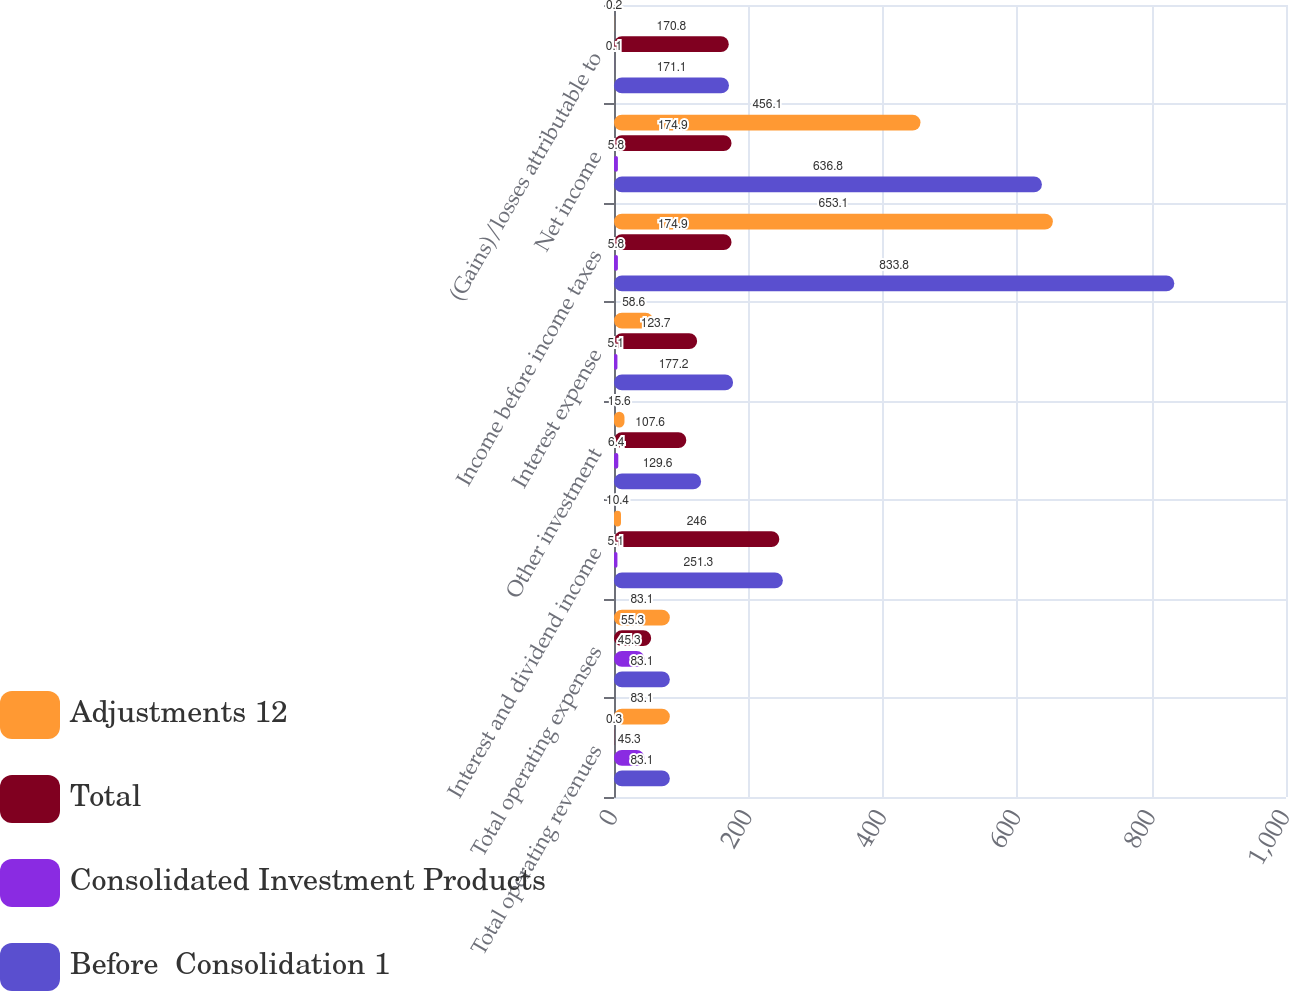<chart> <loc_0><loc_0><loc_500><loc_500><stacked_bar_chart><ecel><fcel>Total operating revenues<fcel>Total operating expenses<fcel>Interest and dividend income<fcel>Other investment<fcel>Interest expense<fcel>Income before income taxes<fcel>Net income<fcel>(Gains)/losses attributable to<nl><fcel>Adjustments 12<fcel>83.1<fcel>83.1<fcel>10.4<fcel>15.6<fcel>58.6<fcel>653.1<fcel>456.1<fcel>0.2<nl><fcel>Total<fcel>0.3<fcel>55.3<fcel>246<fcel>107.6<fcel>123.7<fcel>174.9<fcel>174.9<fcel>170.8<nl><fcel>Consolidated Investment Products<fcel>45.3<fcel>45.3<fcel>5.1<fcel>6.4<fcel>5.1<fcel>5.8<fcel>5.8<fcel>0.1<nl><fcel>Before  Consolidation 1<fcel>83.1<fcel>83.1<fcel>251.3<fcel>129.6<fcel>177.2<fcel>833.8<fcel>636.8<fcel>171.1<nl></chart> 